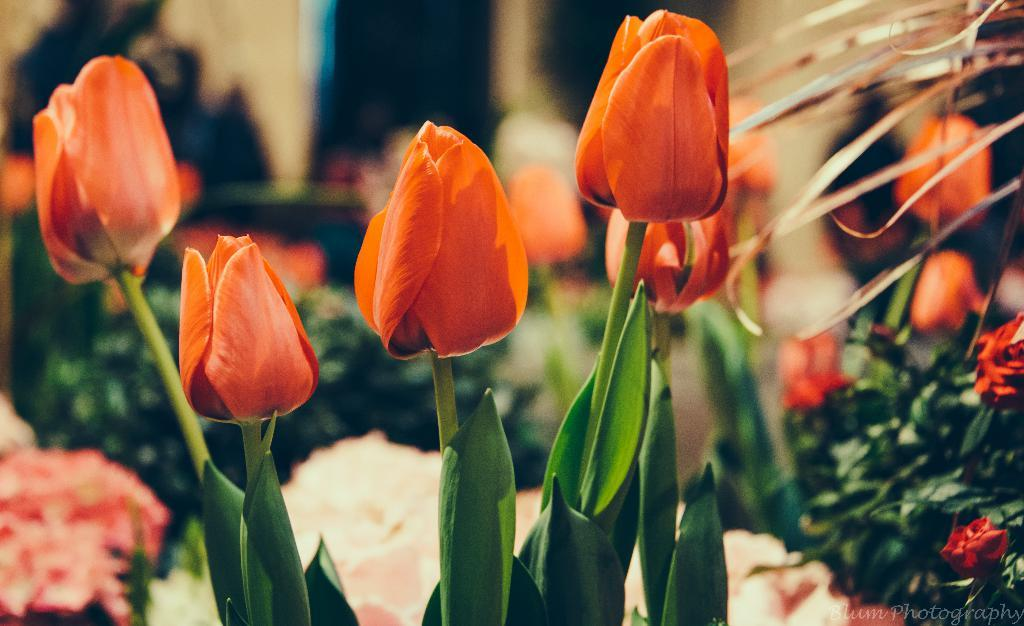What type of living organisms can be seen in the image? There are flowers in the image. Can you describe the background of the image? The background of the image is blurred. What type of protest is taking place in the image? There is no protest present in the image; it features flowers and a blurred background. What scientific discoveries can be observed in the image? There are no scientific discoveries present in the image. 